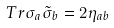<formula> <loc_0><loc_0><loc_500><loc_500>T r \sigma _ { a } \tilde { \sigma } _ { b } = 2 \eta _ { a b }</formula> 